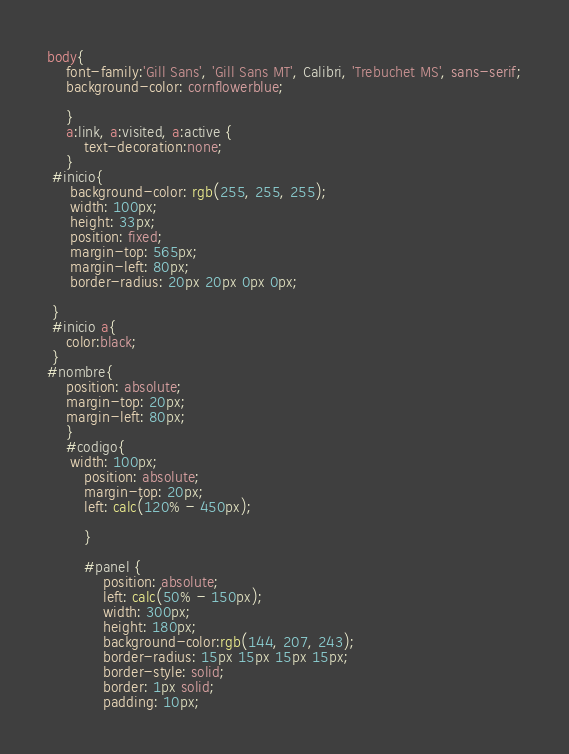<code> <loc_0><loc_0><loc_500><loc_500><_CSS_>body{
    font-family:'Gill Sans', 'Gill Sans MT', Calibri, 'Trebuchet MS', sans-serif;
    background-color: cornflowerblue;
    
    }
    a:link, a:visited, a:active {
        text-decoration:none;
    }
 #inicio{
     background-color: rgb(255, 255, 255);
     width: 100px;
     height: 33px;
     position: fixed;
     margin-top: 565px;
     margin-left: 80px;
     border-radius: 20px 20px 0px 0px;
   
 }
 #inicio a{
    color:black;
 }
#nombre{    
    position: absolute;
    margin-top: 20px;
    margin-left: 80px;
    }
    #codigo{
     width: 100px;
        position: absolute;
        margin-top: 20px;
        left: calc(120% - 450px);
    
        }

        #panel {
            position: absolute;
            left: calc(50% - 150px);
            width: 300px;
            height: 180px;
            background-color:rgb(144, 207, 243);
            border-radius: 15px 15px 15px 15px;
            border-style: solid;
            border: 1px solid;
            padding: 10px;</code> 